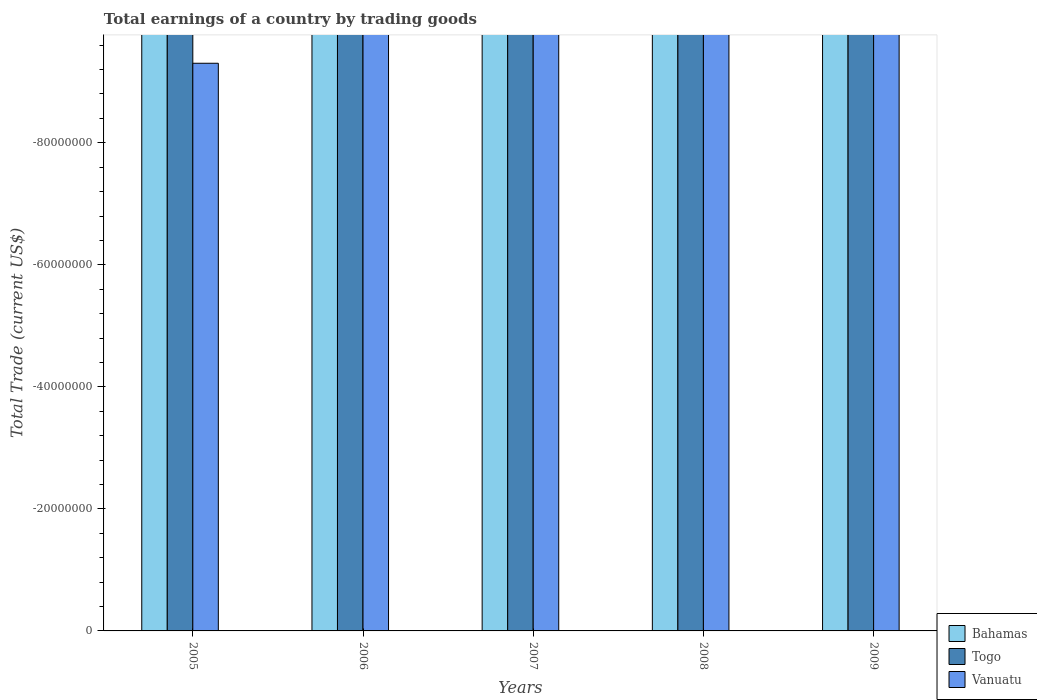How many different coloured bars are there?
Give a very brief answer. 0. Are the number of bars per tick equal to the number of legend labels?
Give a very brief answer. No. In how many cases, is the number of bars for a given year not equal to the number of legend labels?
Give a very brief answer. 5. Across all years, what is the minimum total earnings in Togo?
Offer a very short reply. 0. What is the difference between the total earnings in Bahamas in 2007 and the total earnings in Togo in 2006?
Offer a terse response. 0. In how many years, is the total earnings in Togo greater than the average total earnings in Togo taken over all years?
Provide a short and direct response. 0. How many bars are there?
Offer a very short reply. 0. How many years are there in the graph?
Your answer should be very brief. 5. What is the difference between two consecutive major ticks on the Y-axis?
Ensure brevity in your answer.  2.00e+07. Are the values on the major ticks of Y-axis written in scientific E-notation?
Ensure brevity in your answer.  No. Does the graph contain grids?
Ensure brevity in your answer.  No. How are the legend labels stacked?
Your answer should be compact. Vertical. What is the title of the graph?
Offer a terse response. Total earnings of a country by trading goods. What is the label or title of the Y-axis?
Provide a succinct answer. Total Trade (current US$). What is the Total Trade (current US$) in Vanuatu in 2005?
Make the answer very short. 0. What is the Total Trade (current US$) of Togo in 2006?
Keep it short and to the point. 0. What is the Total Trade (current US$) of Vanuatu in 2006?
Make the answer very short. 0. What is the Total Trade (current US$) in Togo in 2007?
Provide a short and direct response. 0. What is the Total Trade (current US$) of Bahamas in 2008?
Offer a terse response. 0. What is the Total Trade (current US$) in Vanuatu in 2008?
Keep it short and to the point. 0. What is the Total Trade (current US$) of Vanuatu in 2009?
Ensure brevity in your answer.  0. What is the total Total Trade (current US$) in Bahamas in the graph?
Your response must be concise. 0. What is the total Total Trade (current US$) in Togo in the graph?
Offer a terse response. 0. What is the total Total Trade (current US$) in Vanuatu in the graph?
Give a very brief answer. 0. 